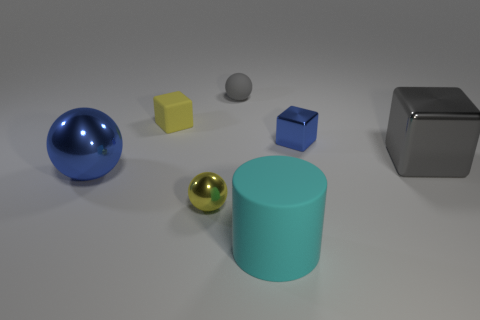How many large objects are either cyan matte things or gray metal things?
Give a very brief answer. 2. What number of big blue objects are in front of the large ball?
Your answer should be compact. 0. What is the color of the other small thing that is the same shape as the gray rubber thing?
Offer a terse response. Yellow. How many rubber objects are either large cylinders or large purple cylinders?
Offer a terse response. 1. There is a small metal object to the left of the gray thing behind the gray cube; are there any metallic blocks in front of it?
Your answer should be very brief. No. The small matte block is what color?
Provide a succinct answer. Yellow. There is a small metal thing that is in front of the blue ball; does it have the same shape as the big blue metallic object?
Offer a very short reply. Yes. How many objects are small gray balls or blocks to the right of the large cylinder?
Provide a short and direct response. 3. Is the material of the gray thing in front of the small blue thing the same as the cylinder?
Your answer should be very brief. No. Are there any other things that are the same size as the yellow matte cube?
Your answer should be compact. Yes. 